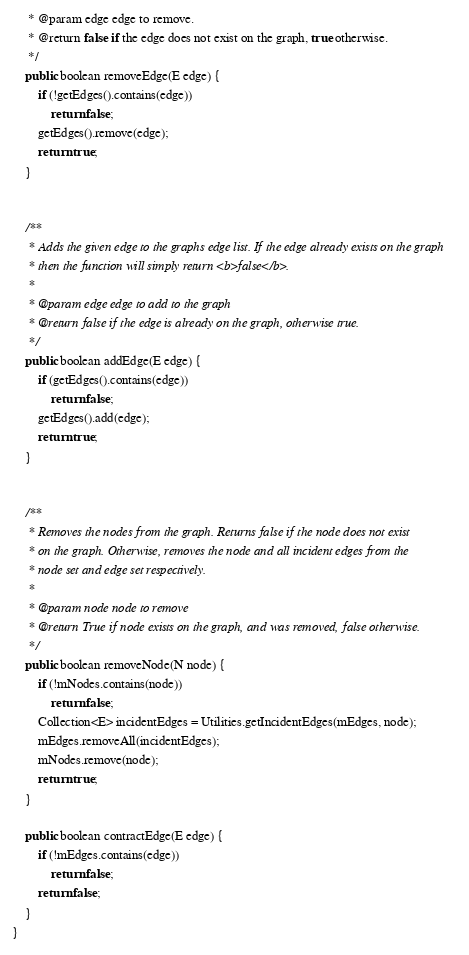Convert code to text. <code><loc_0><loc_0><loc_500><loc_500><_Java_>     * @param edge edge to remove.
     * @return false if the edge does not exist on the graph, true otherwise.
     */
    public boolean removeEdge(E edge) {
        if (!getEdges().contains(edge))
            return false;
        getEdges().remove(edge);
        return true;
    }


    /**
     * Adds the given edge to the graphs edge list. If the edge already exists on the graph
     * then the function will simply return <b>false</b>.
     *
     * @param edge edge to add to the graph
     * @return false if the edge is already on the graph, otherwise true.
     */
    public boolean addEdge(E edge) {
        if (getEdges().contains(edge))
            return false;
        getEdges().add(edge);
        return true;
    }


    /**
     * Removes the nodes from the graph. Returns false if the node does not exist
     * on the graph. Otherwise, removes the node and all incident edges from the
     * node set and edge set respectively.
     *
     * @param node node to remove
     * @return True if node exists on the graph, and was removed, false otherwise.
     */
    public boolean removeNode(N node) {
        if (!mNodes.contains(node))
            return false;
        Collection<E> incidentEdges = Utilities.getIncidentEdges(mEdges, node);
        mEdges.removeAll(incidentEdges);
        mNodes.remove(node);
        return true;
    }

    public boolean contractEdge(E edge) {
        if (!mEdges.contains(edge))
            return false;
        return false;
    }
}
</code> 